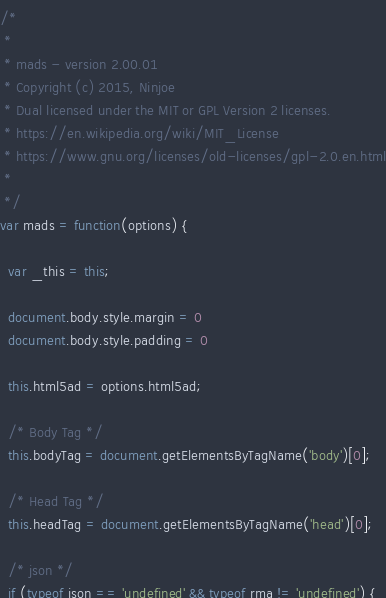<code> <loc_0><loc_0><loc_500><loc_500><_JavaScript_>/*
 *
 * mads - version 2.00.01
 * Copyright (c) 2015, Ninjoe
 * Dual licensed under the MIT or GPL Version 2 licenses.
 * https://en.wikipedia.org/wiki/MIT_License
 * https://www.gnu.org/licenses/old-licenses/gpl-2.0.en.html
 *
 */
var mads = function(options) {

  var _this = this;

  document.body.style.margin = 0
  document.body.style.padding = 0

  this.html5ad = options.html5ad;

  /* Body Tag */
  this.bodyTag = document.getElementsByTagName('body')[0];

  /* Head Tag */
  this.headTag = document.getElementsByTagName('head')[0];

  /* json */
  if (typeof json == 'undefined' && typeof rma != 'undefined') {</code> 